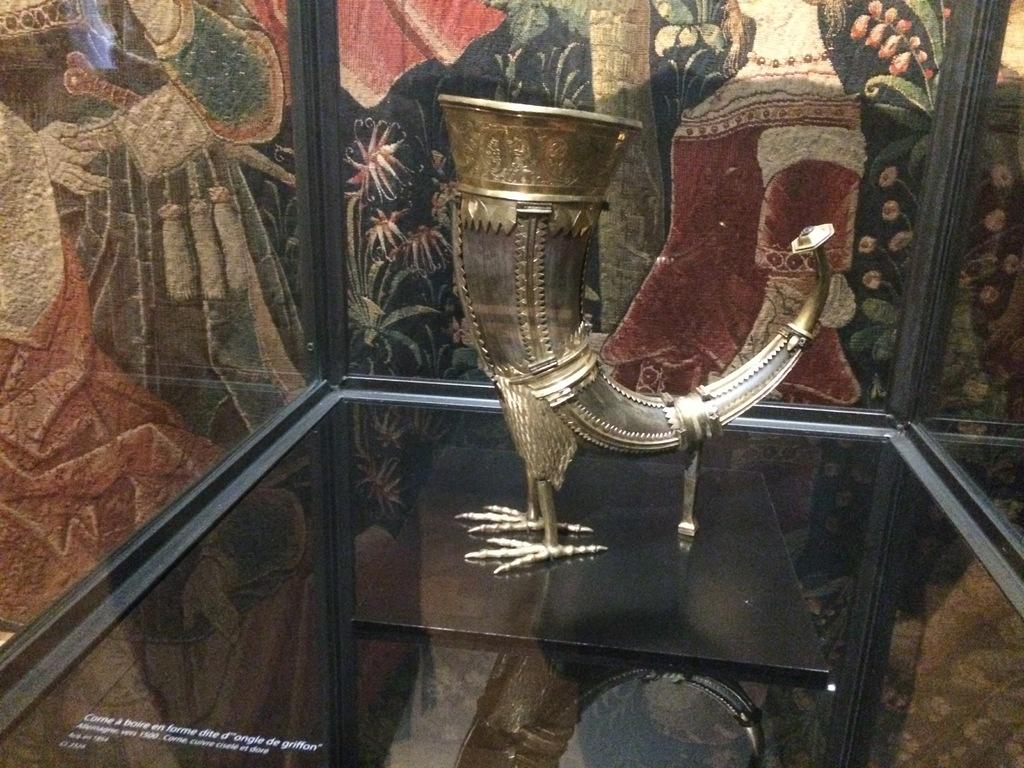What is placed in the glass in the image? There is an object placed in a glass in the image. What can be seen in the background of the image? There is a wall in the background of the image. How many frogs are sitting on the credit in the image? There are no frogs or credits present in the image. What type of fly can be seen buzzing around the object in the glass? There are no flies present in the image. 